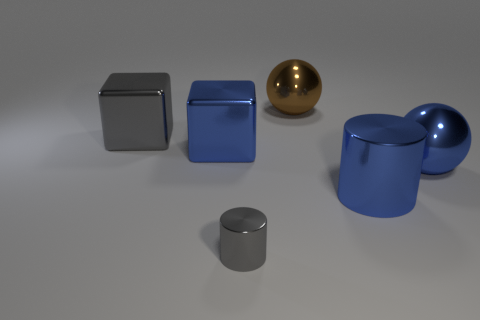Add 3 large blue metallic spheres. How many objects exist? 9 Subtract all cylinders. How many objects are left? 4 Subtract 1 brown balls. How many objects are left? 5 Subtract all large gray shiny blocks. Subtract all small gray cylinders. How many objects are left? 4 Add 2 big blue metallic cylinders. How many big blue metallic cylinders are left? 3 Add 1 large green blocks. How many large green blocks exist? 1 